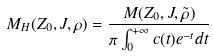Convert formula to latex. <formula><loc_0><loc_0><loc_500><loc_500>M _ { H } ( Z _ { 0 } , J , \rho ) = \frac { M ( Z _ { 0 } , J , \tilde { \rho } ) } { \pi \int _ { 0 } ^ { + \infty } c ( t ) e ^ { - t } d t }</formula> 